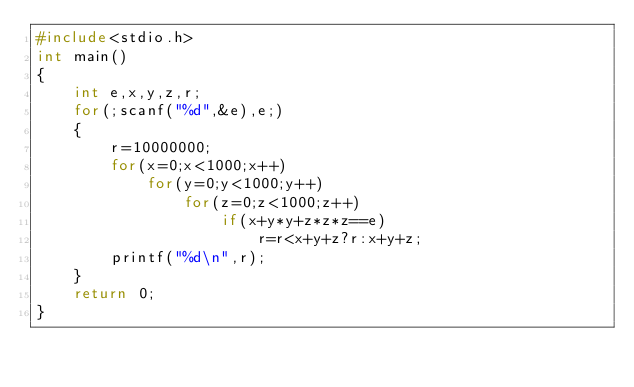Convert code to text. <code><loc_0><loc_0><loc_500><loc_500><_C_>#include<stdio.h>
int main()
{
	int e,x,y,z,r;
	for(;scanf("%d",&e),e;)
	{
		r=10000000;
		for(x=0;x<1000;x++)
			for(y=0;y<1000;y++)
				for(z=0;z<1000;z++)
					if(x+y*y+z*z*z==e)
						r=r<x+y+z?r:x+y+z;
		printf("%d\n",r);
	}
	return 0;
}</code> 